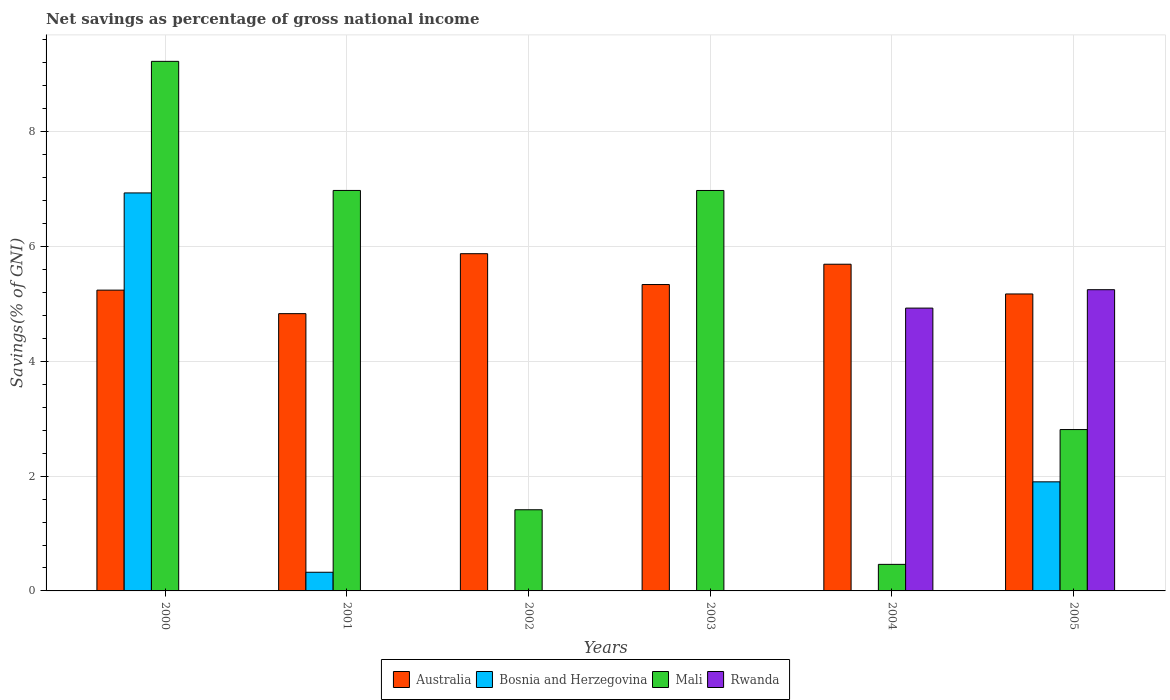How many different coloured bars are there?
Provide a short and direct response. 4. Are the number of bars on each tick of the X-axis equal?
Provide a succinct answer. No. How many bars are there on the 4th tick from the right?
Ensure brevity in your answer.  2. What is the label of the 4th group of bars from the left?
Keep it short and to the point. 2003. In how many cases, is the number of bars for a given year not equal to the number of legend labels?
Keep it short and to the point. 5. What is the total savings in Bosnia and Herzegovina in 2002?
Ensure brevity in your answer.  0. Across all years, what is the maximum total savings in Bosnia and Herzegovina?
Provide a succinct answer. 6.93. In which year was the total savings in Australia maximum?
Ensure brevity in your answer.  2002. What is the total total savings in Bosnia and Herzegovina in the graph?
Your answer should be compact. 9.16. What is the difference between the total savings in Mali in 2001 and that in 2002?
Provide a short and direct response. 5.56. What is the difference between the total savings in Rwanda in 2003 and the total savings in Australia in 2001?
Offer a terse response. -4.83. What is the average total savings in Mali per year?
Offer a very short reply. 4.64. In the year 2005, what is the difference between the total savings in Australia and total savings in Mali?
Your answer should be compact. 2.36. In how many years, is the total savings in Mali greater than 9.2 %?
Your response must be concise. 1. What is the ratio of the total savings in Australia in 2000 to that in 2005?
Give a very brief answer. 1.01. What is the difference between the highest and the second highest total savings in Bosnia and Herzegovina?
Provide a short and direct response. 5.03. What is the difference between the highest and the lowest total savings in Australia?
Provide a short and direct response. 1.04. Is it the case that in every year, the sum of the total savings in Rwanda and total savings in Australia is greater than the total savings in Bosnia and Herzegovina?
Keep it short and to the point. No. How many bars are there?
Give a very brief answer. 17. Are all the bars in the graph horizontal?
Ensure brevity in your answer.  No. How many years are there in the graph?
Provide a succinct answer. 6. Does the graph contain any zero values?
Make the answer very short. Yes. How many legend labels are there?
Provide a short and direct response. 4. What is the title of the graph?
Your answer should be compact. Net savings as percentage of gross national income. What is the label or title of the X-axis?
Ensure brevity in your answer.  Years. What is the label or title of the Y-axis?
Offer a terse response. Savings(% of GNI). What is the Savings(% of GNI) in Australia in 2000?
Ensure brevity in your answer.  5.24. What is the Savings(% of GNI) of Bosnia and Herzegovina in 2000?
Make the answer very short. 6.93. What is the Savings(% of GNI) in Mali in 2000?
Make the answer very short. 9.23. What is the Savings(% of GNI) in Australia in 2001?
Make the answer very short. 4.83. What is the Savings(% of GNI) in Bosnia and Herzegovina in 2001?
Your answer should be compact. 0.33. What is the Savings(% of GNI) of Mali in 2001?
Your response must be concise. 6.98. What is the Savings(% of GNI) of Rwanda in 2001?
Keep it short and to the point. 0. What is the Savings(% of GNI) of Australia in 2002?
Your response must be concise. 5.88. What is the Savings(% of GNI) in Mali in 2002?
Make the answer very short. 1.41. What is the Savings(% of GNI) of Australia in 2003?
Your response must be concise. 5.34. What is the Savings(% of GNI) of Bosnia and Herzegovina in 2003?
Your answer should be compact. 0. What is the Savings(% of GNI) of Mali in 2003?
Your answer should be compact. 6.98. What is the Savings(% of GNI) of Australia in 2004?
Your response must be concise. 5.69. What is the Savings(% of GNI) of Mali in 2004?
Keep it short and to the point. 0.46. What is the Savings(% of GNI) of Rwanda in 2004?
Your response must be concise. 4.93. What is the Savings(% of GNI) in Australia in 2005?
Give a very brief answer. 5.17. What is the Savings(% of GNI) in Bosnia and Herzegovina in 2005?
Keep it short and to the point. 1.9. What is the Savings(% of GNI) in Mali in 2005?
Your answer should be very brief. 2.81. What is the Savings(% of GNI) of Rwanda in 2005?
Offer a very short reply. 5.25. Across all years, what is the maximum Savings(% of GNI) of Australia?
Provide a succinct answer. 5.88. Across all years, what is the maximum Savings(% of GNI) in Bosnia and Herzegovina?
Provide a succinct answer. 6.93. Across all years, what is the maximum Savings(% of GNI) in Mali?
Your answer should be compact. 9.23. Across all years, what is the maximum Savings(% of GNI) in Rwanda?
Offer a very short reply. 5.25. Across all years, what is the minimum Savings(% of GNI) in Australia?
Your answer should be very brief. 4.83. Across all years, what is the minimum Savings(% of GNI) of Mali?
Offer a very short reply. 0.46. What is the total Savings(% of GNI) in Australia in the graph?
Provide a short and direct response. 32.15. What is the total Savings(% of GNI) in Bosnia and Herzegovina in the graph?
Offer a very short reply. 9.16. What is the total Savings(% of GNI) in Mali in the graph?
Ensure brevity in your answer.  27.87. What is the total Savings(% of GNI) in Rwanda in the graph?
Provide a short and direct response. 10.18. What is the difference between the Savings(% of GNI) in Australia in 2000 and that in 2001?
Provide a succinct answer. 0.41. What is the difference between the Savings(% of GNI) in Bosnia and Herzegovina in 2000 and that in 2001?
Provide a succinct answer. 6.61. What is the difference between the Savings(% of GNI) of Mali in 2000 and that in 2001?
Your response must be concise. 2.25. What is the difference between the Savings(% of GNI) of Australia in 2000 and that in 2002?
Your answer should be very brief. -0.63. What is the difference between the Savings(% of GNI) in Mali in 2000 and that in 2002?
Keep it short and to the point. 7.81. What is the difference between the Savings(% of GNI) of Australia in 2000 and that in 2003?
Provide a short and direct response. -0.1. What is the difference between the Savings(% of GNI) in Mali in 2000 and that in 2003?
Your answer should be compact. 2.25. What is the difference between the Savings(% of GNI) of Australia in 2000 and that in 2004?
Your answer should be very brief. -0.45. What is the difference between the Savings(% of GNI) in Mali in 2000 and that in 2004?
Your response must be concise. 8.76. What is the difference between the Savings(% of GNI) of Australia in 2000 and that in 2005?
Keep it short and to the point. 0.07. What is the difference between the Savings(% of GNI) of Bosnia and Herzegovina in 2000 and that in 2005?
Make the answer very short. 5.03. What is the difference between the Savings(% of GNI) of Mali in 2000 and that in 2005?
Offer a terse response. 6.41. What is the difference between the Savings(% of GNI) of Australia in 2001 and that in 2002?
Keep it short and to the point. -1.04. What is the difference between the Savings(% of GNI) in Mali in 2001 and that in 2002?
Make the answer very short. 5.56. What is the difference between the Savings(% of GNI) of Australia in 2001 and that in 2003?
Give a very brief answer. -0.51. What is the difference between the Savings(% of GNI) of Australia in 2001 and that in 2004?
Provide a short and direct response. -0.86. What is the difference between the Savings(% of GNI) in Mali in 2001 and that in 2004?
Offer a terse response. 6.51. What is the difference between the Savings(% of GNI) of Australia in 2001 and that in 2005?
Your response must be concise. -0.34. What is the difference between the Savings(% of GNI) in Bosnia and Herzegovina in 2001 and that in 2005?
Ensure brevity in your answer.  -1.58. What is the difference between the Savings(% of GNI) of Mali in 2001 and that in 2005?
Make the answer very short. 4.17. What is the difference between the Savings(% of GNI) of Australia in 2002 and that in 2003?
Keep it short and to the point. 0.54. What is the difference between the Savings(% of GNI) in Mali in 2002 and that in 2003?
Your response must be concise. -5.56. What is the difference between the Savings(% of GNI) in Australia in 2002 and that in 2004?
Make the answer very short. 0.18. What is the difference between the Savings(% of GNI) in Mali in 2002 and that in 2004?
Provide a succinct answer. 0.95. What is the difference between the Savings(% of GNI) in Australia in 2002 and that in 2005?
Offer a terse response. 0.7. What is the difference between the Savings(% of GNI) of Mali in 2002 and that in 2005?
Offer a very short reply. -1.4. What is the difference between the Savings(% of GNI) in Australia in 2003 and that in 2004?
Keep it short and to the point. -0.35. What is the difference between the Savings(% of GNI) in Mali in 2003 and that in 2004?
Your answer should be very brief. 6.51. What is the difference between the Savings(% of GNI) in Australia in 2003 and that in 2005?
Offer a terse response. 0.16. What is the difference between the Savings(% of GNI) of Mali in 2003 and that in 2005?
Make the answer very short. 4.17. What is the difference between the Savings(% of GNI) in Australia in 2004 and that in 2005?
Provide a short and direct response. 0.52. What is the difference between the Savings(% of GNI) in Mali in 2004 and that in 2005?
Keep it short and to the point. -2.35. What is the difference between the Savings(% of GNI) in Rwanda in 2004 and that in 2005?
Your answer should be very brief. -0.32. What is the difference between the Savings(% of GNI) of Australia in 2000 and the Savings(% of GNI) of Bosnia and Herzegovina in 2001?
Keep it short and to the point. 4.92. What is the difference between the Savings(% of GNI) of Australia in 2000 and the Savings(% of GNI) of Mali in 2001?
Your answer should be compact. -1.74. What is the difference between the Savings(% of GNI) of Bosnia and Herzegovina in 2000 and the Savings(% of GNI) of Mali in 2001?
Keep it short and to the point. -0.04. What is the difference between the Savings(% of GNI) in Australia in 2000 and the Savings(% of GNI) in Mali in 2002?
Your response must be concise. 3.83. What is the difference between the Savings(% of GNI) of Bosnia and Herzegovina in 2000 and the Savings(% of GNI) of Mali in 2002?
Offer a terse response. 5.52. What is the difference between the Savings(% of GNI) of Australia in 2000 and the Savings(% of GNI) of Mali in 2003?
Your response must be concise. -1.74. What is the difference between the Savings(% of GNI) of Bosnia and Herzegovina in 2000 and the Savings(% of GNI) of Mali in 2003?
Provide a succinct answer. -0.04. What is the difference between the Savings(% of GNI) of Australia in 2000 and the Savings(% of GNI) of Mali in 2004?
Ensure brevity in your answer.  4.78. What is the difference between the Savings(% of GNI) in Australia in 2000 and the Savings(% of GNI) in Rwanda in 2004?
Your answer should be very brief. 0.31. What is the difference between the Savings(% of GNI) in Bosnia and Herzegovina in 2000 and the Savings(% of GNI) in Mali in 2004?
Your answer should be compact. 6.47. What is the difference between the Savings(% of GNI) of Bosnia and Herzegovina in 2000 and the Savings(% of GNI) of Rwanda in 2004?
Provide a short and direct response. 2.01. What is the difference between the Savings(% of GNI) in Mali in 2000 and the Savings(% of GNI) in Rwanda in 2004?
Your answer should be very brief. 4.3. What is the difference between the Savings(% of GNI) in Australia in 2000 and the Savings(% of GNI) in Bosnia and Herzegovina in 2005?
Ensure brevity in your answer.  3.34. What is the difference between the Savings(% of GNI) of Australia in 2000 and the Savings(% of GNI) of Mali in 2005?
Offer a very short reply. 2.43. What is the difference between the Savings(% of GNI) of Australia in 2000 and the Savings(% of GNI) of Rwanda in 2005?
Provide a succinct answer. -0.01. What is the difference between the Savings(% of GNI) of Bosnia and Herzegovina in 2000 and the Savings(% of GNI) of Mali in 2005?
Provide a short and direct response. 4.12. What is the difference between the Savings(% of GNI) in Bosnia and Herzegovina in 2000 and the Savings(% of GNI) in Rwanda in 2005?
Your answer should be compact. 1.69. What is the difference between the Savings(% of GNI) in Mali in 2000 and the Savings(% of GNI) in Rwanda in 2005?
Offer a terse response. 3.98. What is the difference between the Savings(% of GNI) in Australia in 2001 and the Savings(% of GNI) in Mali in 2002?
Ensure brevity in your answer.  3.42. What is the difference between the Savings(% of GNI) in Bosnia and Herzegovina in 2001 and the Savings(% of GNI) in Mali in 2002?
Ensure brevity in your answer.  -1.09. What is the difference between the Savings(% of GNI) of Australia in 2001 and the Savings(% of GNI) of Mali in 2003?
Provide a short and direct response. -2.15. What is the difference between the Savings(% of GNI) of Bosnia and Herzegovina in 2001 and the Savings(% of GNI) of Mali in 2003?
Your answer should be very brief. -6.65. What is the difference between the Savings(% of GNI) in Australia in 2001 and the Savings(% of GNI) in Mali in 2004?
Give a very brief answer. 4.37. What is the difference between the Savings(% of GNI) of Australia in 2001 and the Savings(% of GNI) of Rwanda in 2004?
Your response must be concise. -0.1. What is the difference between the Savings(% of GNI) of Bosnia and Herzegovina in 2001 and the Savings(% of GNI) of Mali in 2004?
Offer a very short reply. -0.14. What is the difference between the Savings(% of GNI) of Bosnia and Herzegovina in 2001 and the Savings(% of GNI) of Rwanda in 2004?
Provide a succinct answer. -4.6. What is the difference between the Savings(% of GNI) in Mali in 2001 and the Savings(% of GNI) in Rwanda in 2004?
Provide a short and direct response. 2.05. What is the difference between the Savings(% of GNI) of Australia in 2001 and the Savings(% of GNI) of Bosnia and Herzegovina in 2005?
Provide a short and direct response. 2.93. What is the difference between the Savings(% of GNI) of Australia in 2001 and the Savings(% of GNI) of Mali in 2005?
Give a very brief answer. 2.02. What is the difference between the Savings(% of GNI) in Australia in 2001 and the Savings(% of GNI) in Rwanda in 2005?
Provide a short and direct response. -0.42. What is the difference between the Savings(% of GNI) in Bosnia and Herzegovina in 2001 and the Savings(% of GNI) in Mali in 2005?
Your response must be concise. -2.49. What is the difference between the Savings(% of GNI) of Bosnia and Herzegovina in 2001 and the Savings(% of GNI) of Rwanda in 2005?
Offer a very short reply. -4.92. What is the difference between the Savings(% of GNI) of Mali in 2001 and the Savings(% of GNI) of Rwanda in 2005?
Make the answer very short. 1.73. What is the difference between the Savings(% of GNI) of Australia in 2002 and the Savings(% of GNI) of Mali in 2003?
Make the answer very short. -1.1. What is the difference between the Savings(% of GNI) of Australia in 2002 and the Savings(% of GNI) of Mali in 2004?
Ensure brevity in your answer.  5.41. What is the difference between the Savings(% of GNI) of Australia in 2002 and the Savings(% of GNI) of Rwanda in 2004?
Make the answer very short. 0.95. What is the difference between the Savings(% of GNI) of Mali in 2002 and the Savings(% of GNI) of Rwanda in 2004?
Your answer should be very brief. -3.51. What is the difference between the Savings(% of GNI) in Australia in 2002 and the Savings(% of GNI) in Bosnia and Herzegovina in 2005?
Give a very brief answer. 3.97. What is the difference between the Savings(% of GNI) in Australia in 2002 and the Savings(% of GNI) in Mali in 2005?
Make the answer very short. 3.06. What is the difference between the Savings(% of GNI) in Australia in 2002 and the Savings(% of GNI) in Rwanda in 2005?
Offer a very short reply. 0.63. What is the difference between the Savings(% of GNI) in Mali in 2002 and the Savings(% of GNI) in Rwanda in 2005?
Offer a very short reply. -3.83. What is the difference between the Savings(% of GNI) in Australia in 2003 and the Savings(% of GNI) in Mali in 2004?
Make the answer very short. 4.88. What is the difference between the Savings(% of GNI) in Australia in 2003 and the Savings(% of GNI) in Rwanda in 2004?
Provide a short and direct response. 0.41. What is the difference between the Savings(% of GNI) of Mali in 2003 and the Savings(% of GNI) of Rwanda in 2004?
Ensure brevity in your answer.  2.05. What is the difference between the Savings(% of GNI) of Australia in 2003 and the Savings(% of GNI) of Bosnia and Herzegovina in 2005?
Give a very brief answer. 3.44. What is the difference between the Savings(% of GNI) in Australia in 2003 and the Savings(% of GNI) in Mali in 2005?
Offer a very short reply. 2.53. What is the difference between the Savings(% of GNI) of Australia in 2003 and the Savings(% of GNI) of Rwanda in 2005?
Offer a very short reply. 0.09. What is the difference between the Savings(% of GNI) of Mali in 2003 and the Savings(% of GNI) of Rwanda in 2005?
Your response must be concise. 1.73. What is the difference between the Savings(% of GNI) of Australia in 2004 and the Savings(% of GNI) of Bosnia and Herzegovina in 2005?
Offer a terse response. 3.79. What is the difference between the Savings(% of GNI) of Australia in 2004 and the Savings(% of GNI) of Mali in 2005?
Keep it short and to the point. 2.88. What is the difference between the Savings(% of GNI) in Australia in 2004 and the Savings(% of GNI) in Rwanda in 2005?
Keep it short and to the point. 0.44. What is the difference between the Savings(% of GNI) in Mali in 2004 and the Savings(% of GNI) in Rwanda in 2005?
Keep it short and to the point. -4.79. What is the average Savings(% of GNI) of Australia per year?
Give a very brief answer. 5.36. What is the average Savings(% of GNI) of Bosnia and Herzegovina per year?
Offer a terse response. 1.53. What is the average Savings(% of GNI) of Mali per year?
Your answer should be very brief. 4.64. What is the average Savings(% of GNI) of Rwanda per year?
Offer a terse response. 1.7. In the year 2000, what is the difference between the Savings(% of GNI) in Australia and Savings(% of GNI) in Bosnia and Herzegovina?
Provide a succinct answer. -1.69. In the year 2000, what is the difference between the Savings(% of GNI) of Australia and Savings(% of GNI) of Mali?
Provide a short and direct response. -3.99. In the year 2000, what is the difference between the Savings(% of GNI) of Bosnia and Herzegovina and Savings(% of GNI) of Mali?
Offer a very short reply. -2.29. In the year 2001, what is the difference between the Savings(% of GNI) of Australia and Savings(% of GNI) of Bosnia and Herzegovina?
Offer a very short reply. 4.51. In the year 2001, what is the difference between the Savings(% of GNI) of Australia and Savings(% of GNI) of Mali?
Your answer should be very brief. -2.15. In the year 2001, what is the difference between the Savings(% of GNI) of Bosnia and Herzegovina and Savings(% of GNI) of Mali?
Offer a terse response. -6.65. In the year 2002, what is the difference between the Savings(% of GNI) in Australia and Savings(% of GNI) in Mali?
Give a very brief answer. 4.46. In the year 2003, what is the difference between the Savings(% of GNI) of Australia and Savings(% of GNI) of Mali?
Offer a very short reply. -1.64. In the year 2004, what is the difference between the Savings(% of GNI) in Australia and Savings(% of GNI) in Mali?
Ensure brevity in your answer.  5.23. In the year 2004, what is the difference between the Savings(% of GNI) in Australia and Savings(% of GNI) in Rwanda?
Ensure brevity in your answer.  0.76. In the year 2004, what is the difference between the Savings(% of GNI) in Mali and Savings(% of GNI) in Rwanda?
Your response must be concise. -4.46. In the year 2005, what is the difference between the Savings(% of GNI) of Australia and Savings(% of GNI) of Bosnia and Herzegovina?
Make the answer very short. 3.27. In the year 2005, what is the difference between the Savings(% of GNI) of Australia and Savings(% of GNI) of Mali?
Offer a very short reply. 2.36. In the year 2005, what is the difference between the Savings(% of GNI) of Australia and Savings(% of GNI) of Rwanda?
Ensure brevity in your answer.  -0.07. In the year 2005, what is the difference between the Savings(% of GNI) in Bosnia and Herzegovina and Savings(% of GNI) in Mali?
Give a very brief answer. -0.91. In the year 2005, what is the difference between the Savings(% of GNI) in Bosnia and Herzegovina and Savings(% of GNI) in Rwanda?
Your response must be concise. -3.35. In the year 2005, what is the difference between the Savings(% of GNI) of Mali and Savings(% of GNI) of Rwanda?
Your answer should be very brief. -2.44. What is the ratio of the Savings(% of GNI) in Australia in 2000 to that in 2001?
Provide a short and direct response. 1.08. What is the ratio of the Savings(% of GNI) of Bosnia and Herzegovina in 2000 to that in 2001?
Ensure brevity in your answer.  21.33. What is the ratio of the Savings(% of GNI) in Mali in 2000 to that in 2001?
Keep it short and to the point. 1.32. What is the ratio of the Savings(% of GNI) of Australia in 2000 to that in 2002?
Make the answer very short. 0.89. What is the ratio of the Savings(% of GNI) of Mali in 2000 to that in 2002?
Offer a very short reply. 6.53. What is the ratio of the Savings(% of GNI) of Australia in 2000 to that in 2003?
Make the answer very short. 0.98. What is the ratio of the Savings(% of GNI) of Mali in 2000 to that in 2003?
Make the answer very short. 1.32. What is the ratio of the Savings(% of GNI) in Australia in 2000 to that in 2004?
Offer a very short reply. 0.92. What is the ratio of the Savings(% of GNI) of Mali in 2000 to that in 2004?
Make the answer very short. 19.95. What is the ratio of the Savings(% of GNI) of Australia in 2000 to that in 2005?
Keep it short and to the point. 1.01. What is the ratio of the Savings(% of GNI) of Bosnia and Herzegovina in 2000 to that in 2005?
Give a very brief answer. 3.65. What is the ratio of the Savings(% of GNI) in Mali in 2000 to that in 2005?
Keep it short and to the point. 3.28. What is the ratio of the Savings(% of GNI) of Australia in 2001 to that in 2002?
Keep it short and to the point. 0.82. What is the ratio of the Savings(% of GNI) in Mali in 2001 to that in 2002?
Your response must be concise. 4.93. What is the ratio of the Savings(% of GNI) in Australia in 2001 to that in 2003?
Offer a very short reply. 0.91. What is the ratio of the Savings(% of GNI) of Australia in 2001 to that in 2004?
Keep it short and to the point. 0.85. What is the ratio of the Savings(% of GNI) in Mali in 2001 to that in 2004?
Provide a succinct answer. 15.08. What is the ratio of the Savings(% of GNI) in Australia in 2001 to that in 2005?
Provide a succinct answer. 0.93. What is the ratio of the Savings(% of GNI) of Bosnia and Herzegovina in 2001 to that in 2005?
Offer a very short reply. 0.17. What is the ratio of the Savings(% of GNI) in Mali in 2001 to that in 2005?
Offer a very short reply. 2.48. What is the ratio of the Savings(% of GNI) of Australia in 2002 to that in 2003?
Your response must be concise. 1.1. What is the ratio of the Savings(% of GNI) of Mali in 2002 to that in 2003?
Make the answer very short. 0.2. What is the ratio of the Savings(% of GNI) in Australia in 2002 to that in 2004?
Keep it short and to the point. 1.03. What is the ratio of the Savings(% of GNI) in Mali in 2002 to that in 2004?
Make the answer very short. 3.06. What is the ratio of the Savings(% of GNI) of Australia in 2002 to that in 2005?
Provide a short and direct response. 1.14. What is the ratio of the Savings(% of GNI) of Mali in 2002 to that in 2005?
Make the answer very short. 0.5. What is the ratio of the Savings(% of GNI) in Australia in 2003 to that in 2004?
Make the answer very short. 0.94. What is the ratio of the Savings(% of GNI) in Mali in 2003 to that in 2004?
Provide a short and direct response. 15.08. What is the ratio of the Savings(% of GNI) in Australia in 2003 to that in 2005?
Offer a terse response. 1.03. What is the ratio of the Savings(% of GNI) in Mali in 2003 to that in 2005?
Make the answer very short. 2.48. What is the ratio of the Savings(% of GNI) of Australia in 2004 to that in 2005?
Offer a very short reply. 1.1. What is the ratio of the Savings(% of GNI) of Mali in 2004 to that in 2005?
Offer a terse response. 0.16. What is the ratio of the Savings(% of GNI) of Rwanda in 2004 to that in 2005?
Offer a terse response. 0.94. What is the difference between the highest and the second highest Savings(% of GNI) in Australia?
Offer a terse response. 0.18. What is the difference between the highest and the second highest Savings(% of GNI) of Bosnia and Herzegovina?
Ensure brevity in your answer.  5.03. What is the difference between the highest and the second highest Savings(% of GNI) in Mali?
Provide a short and direct response. 2.25. What is the difference between the highest and the lowest Savings(% of GNI) of Australia?
Keep it short and to the point. 1.04. What is the difference between the highest and the lowest Savings(% of GNI) in Bosnia and Herzegovina?
Offer a terse response. 6.93. What is the difference between the highest and the lowest Savings(% of GNI) in Mali?
Your answer should be very brief. 8.76. What is the difference between the highest and the lowest Savings(% of GNI) in Rwanda?
Give a very brief answer. 5.25. 